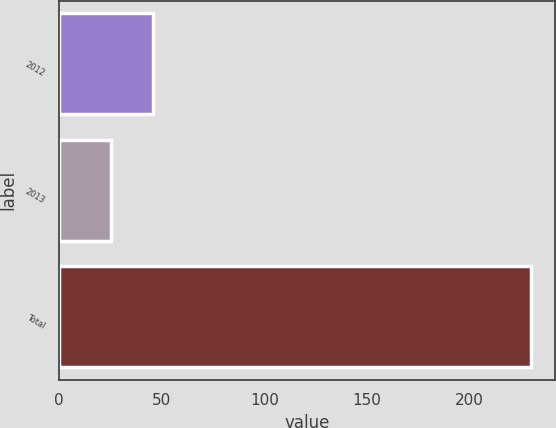Convert chart to OTSL. <chart><loc_0><loc_0><loc_500><loc_500><bar_chart><fcel>2012<fcel>2013<fcel>Total<nl><fcel>45.5<fcel>25<fcel>230<nl></chart> 